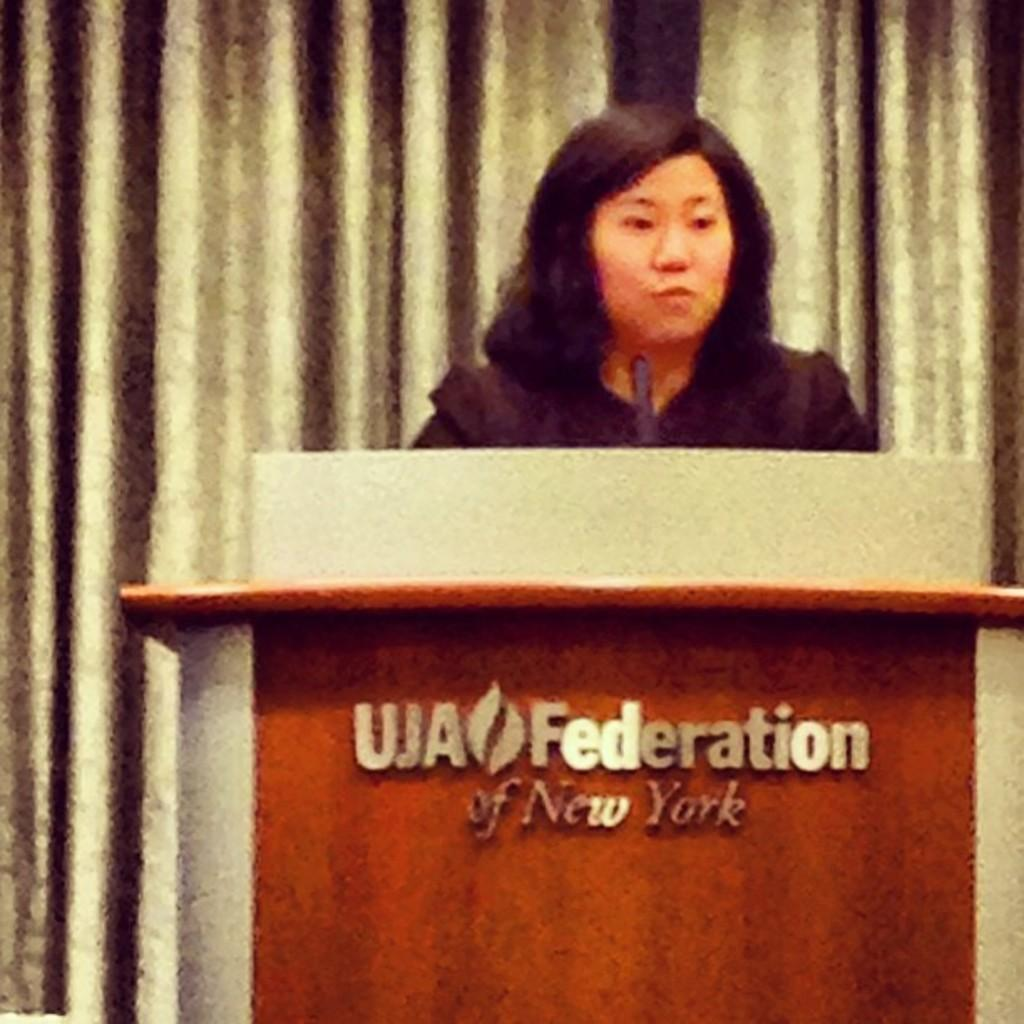Who is the main subject in the picture? There is a woman in the picture. What is the woman doing or standing near in the image? The woman is near a podium. What object is present for the purpose of amplifying sound? There is a microphone present. What can be seen on the podium? There is text on the podium. What is visible behind the woman? There is a curtain behind the woman. Can you see a bottle of water on the podium? There is no bottle of water present on the podium in the image. Is there a goat standing next to the woman? There is no goat present in the image. 